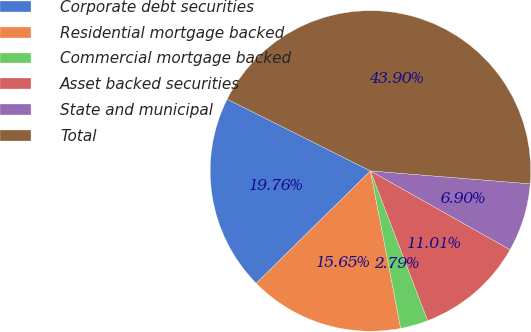<chart> <loc_0><loc_0><loc_500><loc_500><pie_chart><fcel>Corporate debt securities<fcel>Residential mortgage backed<fcel>Commercial mortgage backed<fcel>Asset backed securities<fcel>State and municipal<fcel>Total<nl><fcel>19.76%<fcel>15.65%<fcel>2.79%<fcel>11.01%<fcel>6.9%<fcel>43.9%<nl></chart> 